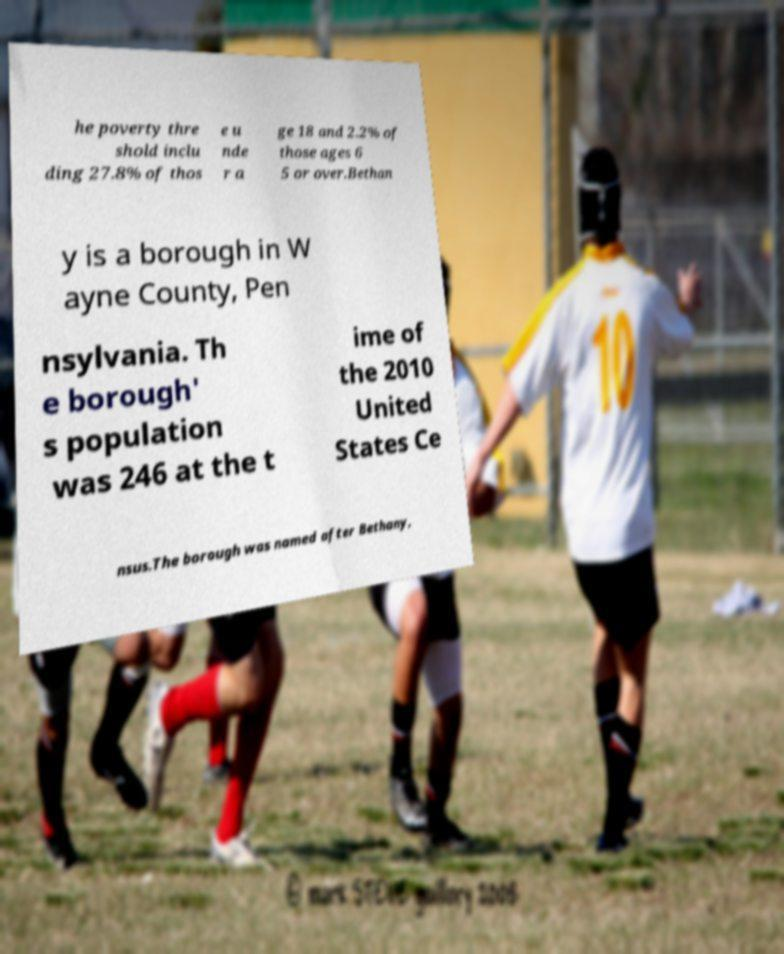Can you accurately transcribe the text from the provided image for me? he poverty thre shold inclu ding 27.8% of thos e u nde r a ge 18 and 2.2% of those ages 6 5 or over.Bethan y is a borough in W ayne County, Pen nsylvania. Th e borough' s population was 246 at the t ime of the 2010 United States Ce nsus.The borough was named after Bethany, 